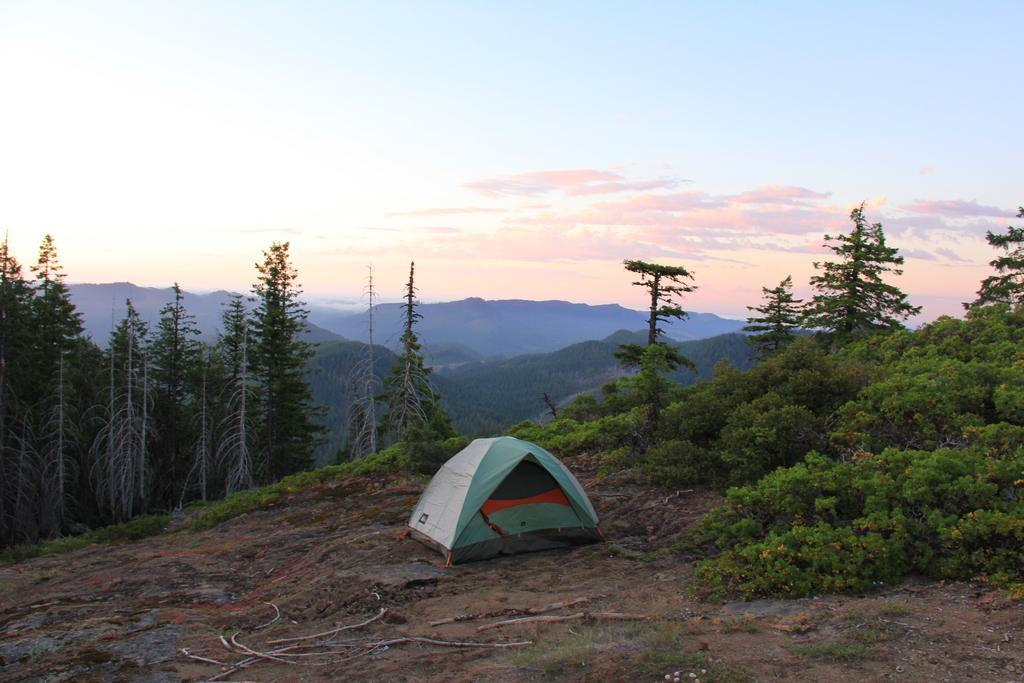How would you summarize this image in a sentence or two? In this picture at front we can see a tent and at the back side there are trees, mountains and sky. 